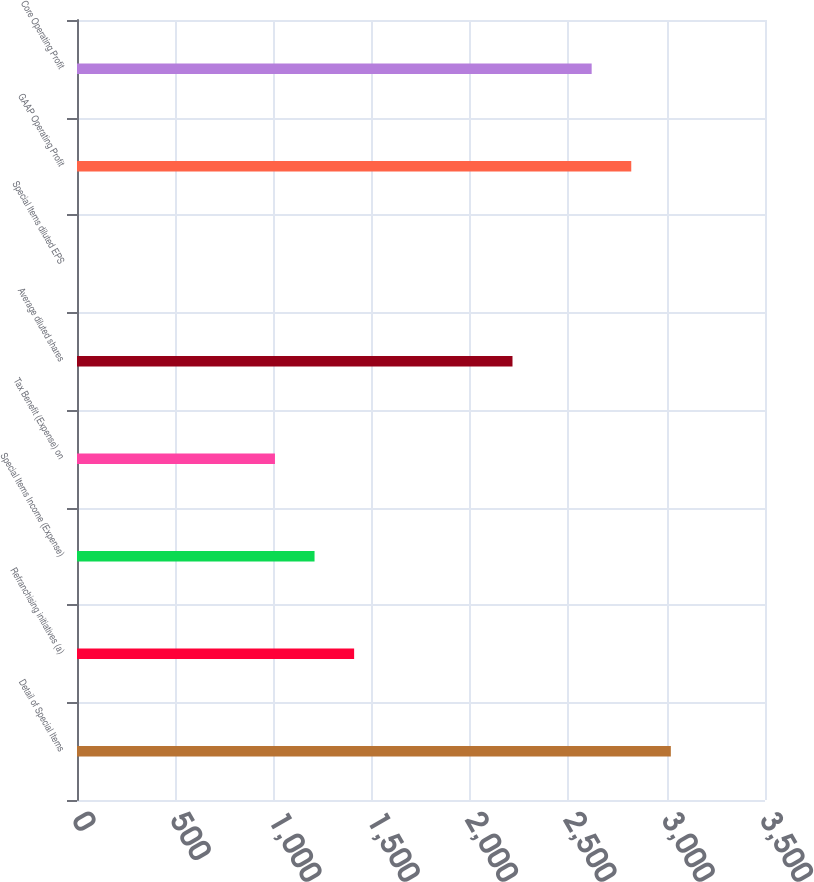Convert chart to OTSL. <chart><loc_0><loc_0><loc_500><loc_500><bar_chart><fcel>Detail of Special Items<fcel>Refranchising initiatives (a)<fcel>Special Items Income (Expense)<fcel>Tax Benefit (Expense) on<fcel>Average diluted shares<fcel>Special Items diluted EPS<fcel>GAAP Operating Profit<fcel>Core Operating Profit<nl><fcel>3021.02<fcel>1409.82<fcel>1208.42<fcel>1007.02<fcel>2215.42<fcel>0.02<fcel>2819.62<fcel>2618.22<nl></chart> 